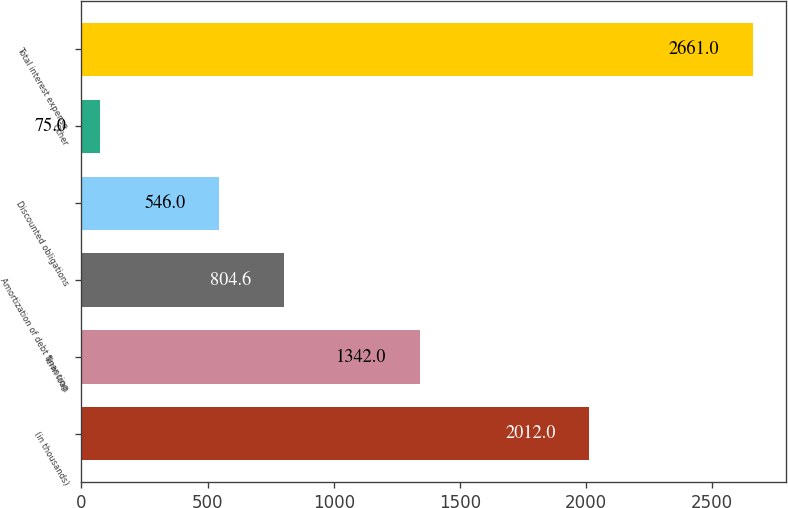Convert chart. <chart><loc_0><loc_0><loc_500><loc_500><bar_chart><fcel>(in thousands)<fcel>Term loan<fcel>Amortization of debt financing<fcel>Discounted obligations<fcel>Other<fcel>Total interest expense<nl><fcel>2012<fcel>1342<fcel>804.6<fcel>546<fcel>75<fcel>2661<nl></chart> 